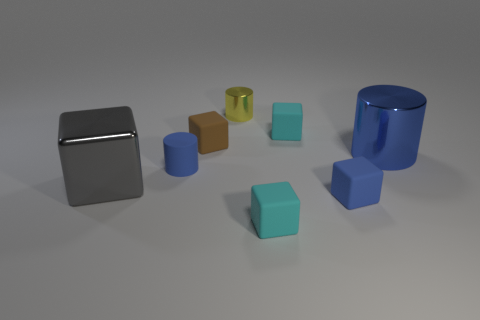What number of tiny yellow metallic things are the same shape as the blue shiny thing?
Ensure brevity in your answer.  1. What color is the shiny object that is both on the left side of the blue block and on the right side of the large gray metallic thing?
Provide a short and direct response. Yellow. How many blue cylinders are there?
Your answer should be compact. 2. Do the brown block and the shiny block have the same size?
Your answer should be very brief. No. Is there a tiny cylinder of the same color as the large shiny cube?
Offer a terse response. No. Does the cyan thing that is in front of the large cylinder have the same shape as the large gray shiny object?
Provide a short and direct response. Yes. How many blue cylinders have the same size as the gray object?
Offer a very short reply. 1. There is a large metal thing that is right of the gray object; how many small matte things are behind it?
Your answer should be very brief. 2. Is the material of the cyan thing that is behind the gray cube the same as the brown thing?
Make the answer very short. Yes. Is the material of the blue thing in front of the gray shiny block the same as the tiny cylinder that is behind the large blue cylinder?
Ensure brevity in your answer.  No. 